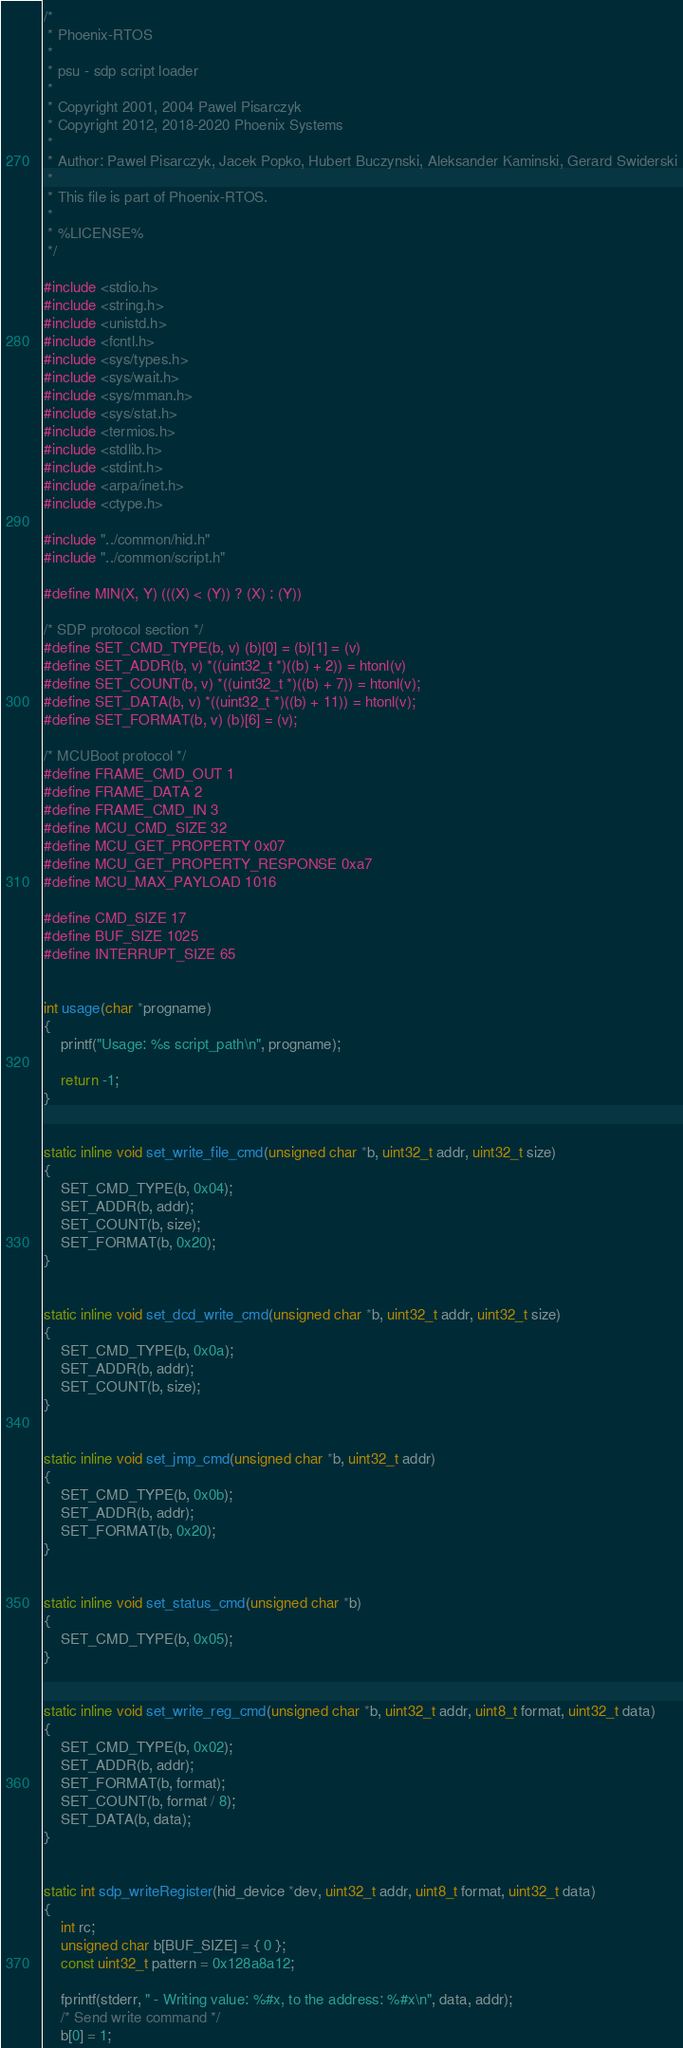<code> <loc_0><loc_0><loc_500><loc_500><_C_>/*
 * Phoenix-RTOS
 *
 * psu - sdp script loader
 *
 * Copyright 2001, 2004 Pawel Pisarczyk
 * Copyright 2012, 2018-2020 Phoenix Systems
 *
 * Author: Pawel Pisarczyk, Jacek Popko, Hubert Buczynski, Aleksander Kaminski, Gerard Swiderski
 *
 * This file is part of Phoenix-RTOS.
 *
 * %LICENSE%
 */

#include <stdio.h>
#include <string.h>
#include <unistd.h>
#include <fcntl.h>
#include <sys/types.h>
#include <sys/wait.h>
#include <sys/mman.h>
#include <sys/stat.h>
#include <termios.h>
#include <stdlib.h>
#include <stdint.h>
#include <arpa/inet.h>
#include <ctype.h>

#include "../common/hid.h"
#include "../common/script.h"

#define MIN(X, Y) (((X) < (Y)) ? (X) : (Y))

/* SDP protocol section */
#define SET_CMD_TYPE(b, v) (b)[0] = (b)[1] = (v)
#define SET_ADDR(b, v) *((uint32_t *)((b) + 2)) = htonl(v)
#define SET_COUNT(b, v) *((uint32_t *)((b) + 7)) = htonl(v);
#define SET_DATA(b, v) *((uint32_t *)((b) + 11)) = htonl(v);
#define SET_FORMAT(b, v) (b)[6] = (v);

/* MCUBoot protocol */
#define FRAME_CMD_OUT 1
#define FRAME_DATA 2
#define FRAME_CMD_IN 3
#define MCU_CMD_SIZE 32
#define MCU_GET_PROPERTY 0x07
#define MCU_GET_PROPERTY_RESPONSE 0xa7
#define MCU_MAX_PAYLOAD 1016

#define CMD_SIZE 17
#define BUF_SIZE 1025
#define INTERRUPT_SIZE 65


int usage(char *progname)
{
	printf("Usage: %s script_path\n", progname);

	return -1;
}


static inline void set_write_file_cmd(unsigned char *b, uint32_t addr, uint32_t size)
{
	SET_CMD_TYPE(b, 0x04);
	SET_ADDR(b, addr);
	SET_COUNT(b, size);
	SET_FORMAT(b, 0x20);
}


static inline void set_dcd_write_cmd(unsigned char *b, uint32_t addr, uint32_t size)
{
	SET_CMD_TYPE(b, 0x0a);
	SET_ADDR(b, addr);
	SET_COUNT(b, size);
}


static inline void set_jmp_cmd(unsigned char *b, uint32_t addr)
{
	SET_CMD_TYPE(b, 0x0b);
	SET_ADDR(b, addr);
	SET_FORMAT(b, 0x20);
}


static inline void set_status_cmd(unsigned char *b)
{
	SET_CMD_TYPE(b, 0x05);
}


static inline void set_write_reg_cmd(unsigned char *b, uint32_t addr, uint8_t format, uint32_t data)
{
	SET_CMD_TYPE(b, 0x02);
	SET_ADDR(b, addr);
	SET_FORMAT(b, format);
	SET_COUNT(b, format / 8);
	SET_DATA(b, data);
}


static int sdp_writeRegister(hid_device *dev, uint32_t addr, uint8_t format, uint32_t data)
{
	int rc;
	unsigned char b[BUF_SIZE] = { 0 };
	const uint32_t pattern = 0x128a8a12;

	fprintf(stderr, " - Writing value: %#x, to the address: %#x\n", data, addr);
	/* Send write command */
	b[0] = 1;</code> 